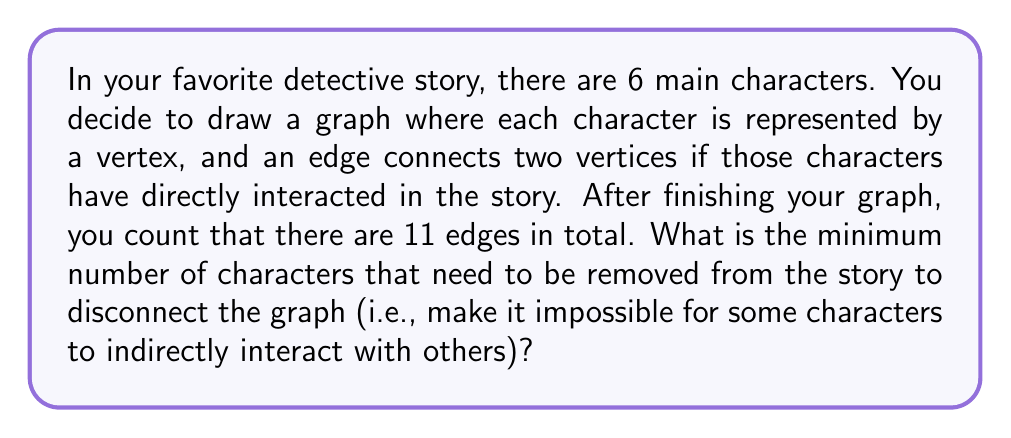Teach me how to tackle this problem. Let's approach this step-by-step using graph theory concepts:

1) First, we need to understand what the question is asking. We're looking for the vertex connectivity of the graph, which is the minimum number of vertices that need to be removed to disconnect the graph.

2) We're given that the graph has 6 vertices (characters) and 11 edges (interactions).

3) To determine the vertex connectivity, we can use a theorem from graph theory: For a graph G that is not complete, the vertex connectivity κ(G) is always less than or equal to the minimum degree δ(G) of the graph.

4) In a complete graph with 6 vertices, there would be $\binom{6}{2} = 15$ edges. Since our graph has 11 edges, it's not complete.

5) To find the minimum degree, let's consider the maximum possible degree for each vertex:
   - If one vertex had degree 5, that would account for 5 edges.
   - The remaining 6 edges distributed among the other 5 vertices means at least one vertex must have degree 2 or less.

6) Therefore, the minimum degree δ(G) is at most 2.

7) Given that κ(G) ≤ δ(G) ≤ 2, the vertex connectivity must be either 1 or 2.

8) If κ(G) were 1, that would mean the graph has a cut-vertex (a single vertex whose removal disconnects the graph). However, with 11 edges among 6 vertices, it's unlikely that removing any single vertex would disconnect the graph.

9) Therefore, we can conclude that the vertex connectivity κ(G) is most likely 2.

This means that removing any 2 vertices (characters) would be sufficient and necessary to disconnect the graph (make it impossible for some characters to indirectly interact with others).
Answer: 2 characters 